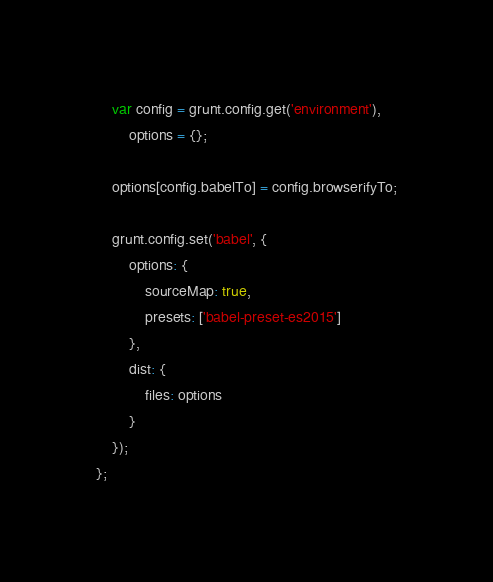Convert code to text. <code><loc_0><loc_0><loc_500><loc_500><_JavaScript_>
    var config = grunt.config.get('environment'),
        options = {};

    options[config.babelTo] = config.browserifyTo;

    grunt.config.set('babel', {
        options: {
            sourceMap: true,
            presets: ['babel-preset-es2015']
        },
        dist: {
            files: options
        }
    });
};
</code> 